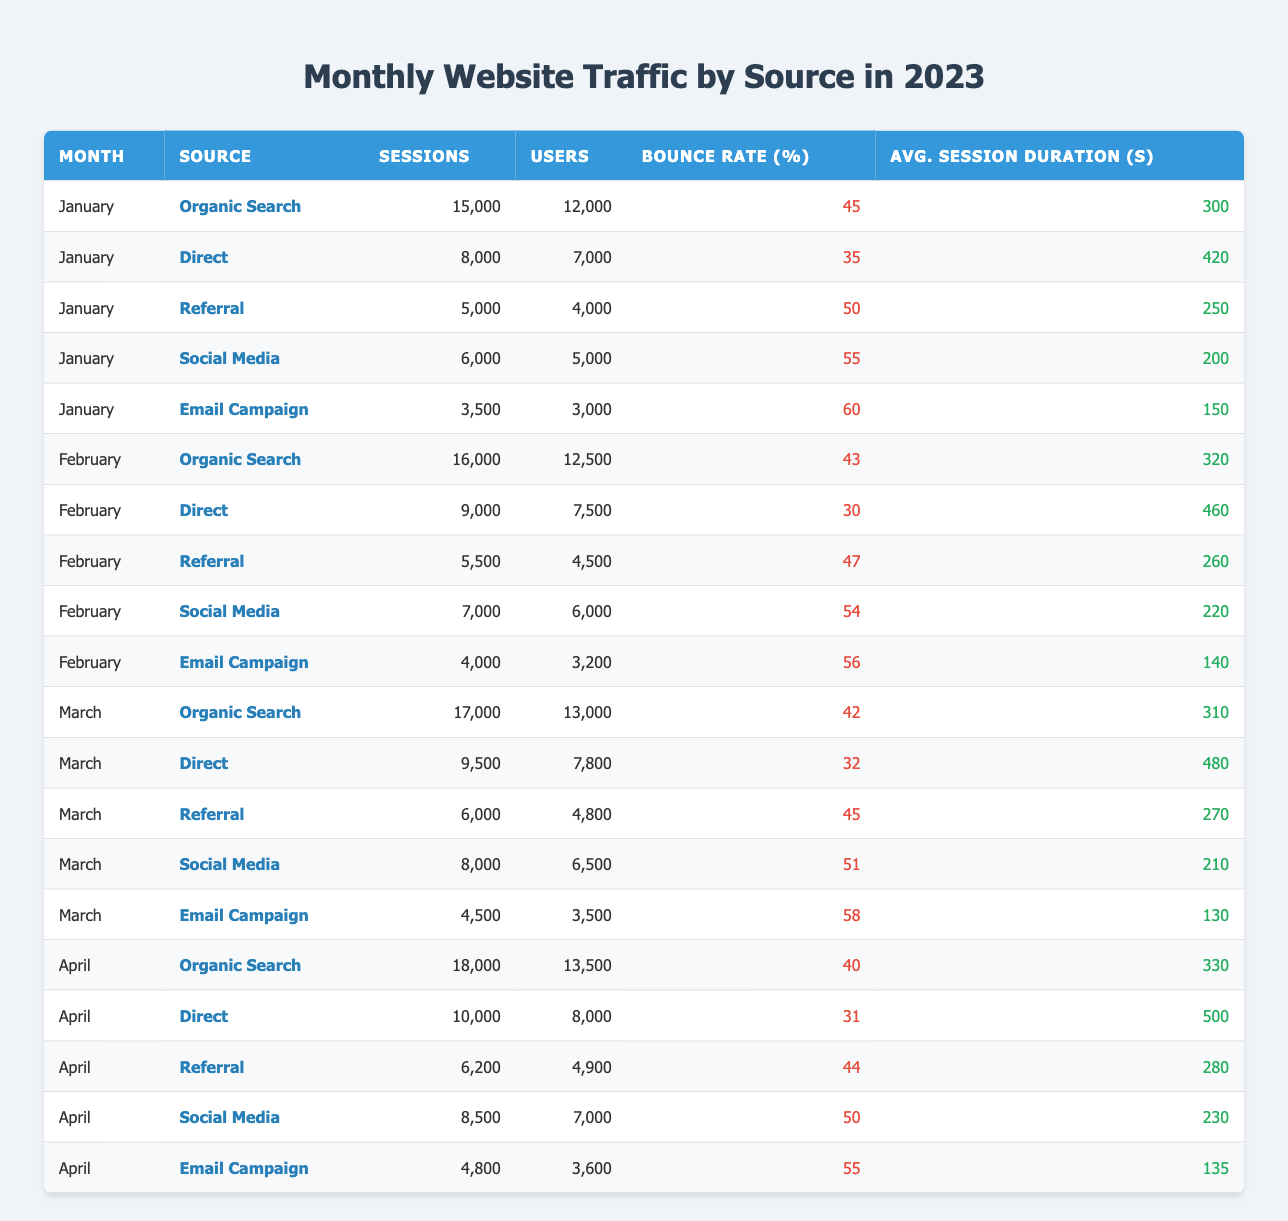What's the highest number of sessions recorded in January? In January, the source with the highest number of sessions is "Organic Search" with 15,000 sessions.
Answer: 15,000 What is the average bounce rate for Email Campaign across the four months? The bounce rates for Email Campaign are 60, 56, 58, and 55. Summing these gives 60 + 56 + 58 + 55 = 229. There are 4 entries, so the average bounce rate is 229 / 4 = 57.25.
Answer: 57.25 Was the number of users from Direct traffic greater than that from Social Media in February? In February, the number of users from Direct traffic is 7,500, while from Social Media it is 6,000. Since 7,500 is greater than 6,000, the answer is yes.
Answer: Yes How much did the number of sessions from Organic Search increase from January to April? In January, the sessions for Organic Search are 15,000, and in April, they are 18,000. The difference is 18,000 - 15,000 = 3,000 sessions.
Answer: 3,000 What was the total number of users across all sources in March? The users for each source in March are: 13,000 (Organic Search) + 7,800 (Direct) + 4,800 (Referral) + 6,500 (Social Media) + 3,500 (Email Campaign). Adding these gives 13,000 + 7,800 + 4,800 + 6,500 + 3,500 = 35,600 users.
Answer: 35,600 Did the average session duration for Direct traffic increase or decrease from February to April? In February, the average session duration for Direct traffic is 460 seconds, and in April, it is 500 seconds. Since 500 is greater than 460, we conclude that it increased.
Answer: Increased What was the highest bounce rate recorded for any source in January? The highest bounce rate in January is from "Email Campaign," which has a bounce rate of 60%.
Answer: 60 Which traffic source had the lowest number of sessions in February? In February, "Email Campaign" had the lowest number of sessions at 4,000 compared to other sources.
Answer: 4,000 How many users came from Referral traffic in April? In April, the number of users from Referral traffic is 4,900, as stated in the table.
Answer: 4,900 